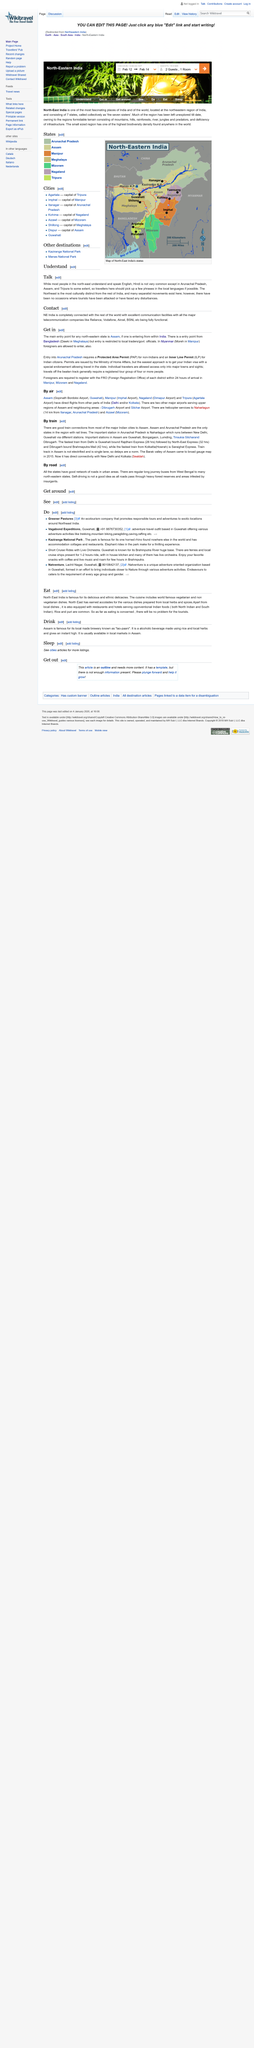Mention a couple of crucial points in this snapshot. The Northeast region of India is the most culturally distinct area of the country, exhibiting unique customs and traditions that distinguish it from the rest of India. There are seven states that make up North Eastern India. The seven states of north-east India are collectively known as the seven Sisters. Hindi is commonly spoken in the northeast region of India, specifically in Arunachal Pradesh, Assam, and Tripura, with varying degrees of proficiency. Yes, it is true that the majority of people in the Northeast region of India are proficient in English and understand it. 